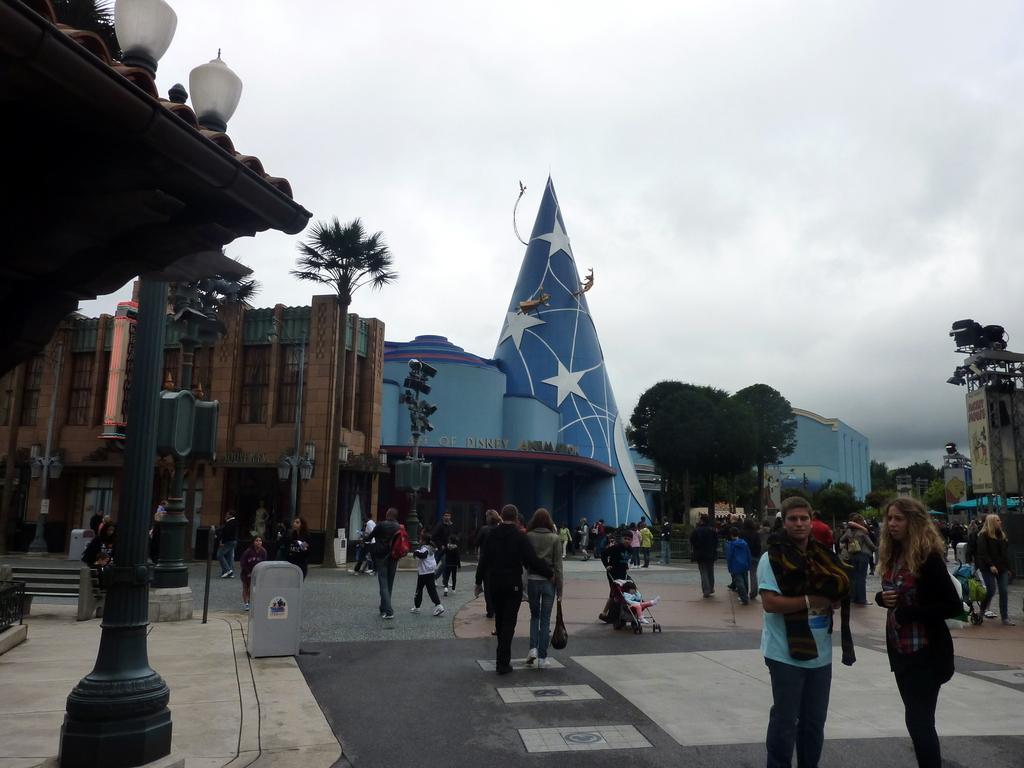How would you summarize this image in a sentence or two? In this image we can see a few people on the floor, there are some buildings, trees, poles and lights, in the background we can see the sky. 